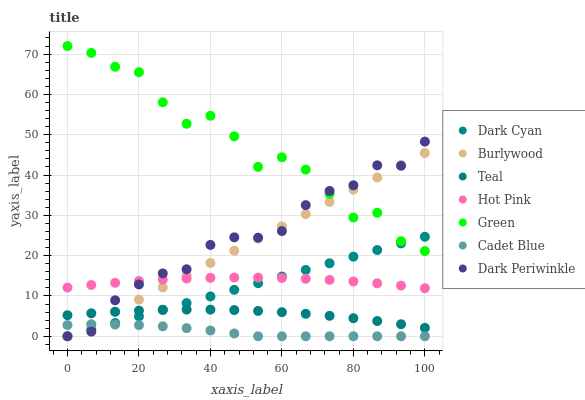Does Cadet Blue have the minimum area under the curve?
Answer yes or no. Yes. Does Green have the maximum area under the curve?
Answer yes or no. Yes. Does Burlywood have the minimum area under the curve?
Answer yes or no. No. Does Burlywood have the maximum area under the curve?
Answer yes or no. No. Is Dark Cyan the smoothest?
Answer yes or no. Yes. Is Green the roughest?
Answer yes or no. Yes. Is Burlywood the smoothest?
Answer yes or no. No. Is Burlywood the roughest?
Answer yes or no. No. Does Cadet Blue have the lowest value?
Answer yes or no. Yes. Does Hot Pink have the lowest value?
Answer yes or no. No. Does Green have the highest value?
Answer yes or no. Yes. Does Burlywood have the highest value?
Answer yes or no. No. Is Hot Pink less than Green?
Answer yes or no. Yes. Is Hot Pink greater than Cadet Blue?
Answer yes or no. Yes. Does Dark Periwinkle intersect Hot Pink?
Answer yes or no. Yes. Is Dark Periwinkle less than Hot Pink?
Answer yes or no. No. Is Dark Periwinkle greater than Hot Pink?
Answer yes or no. No. Does Hot Pink intersect Green?
Answer yes or no. No. 